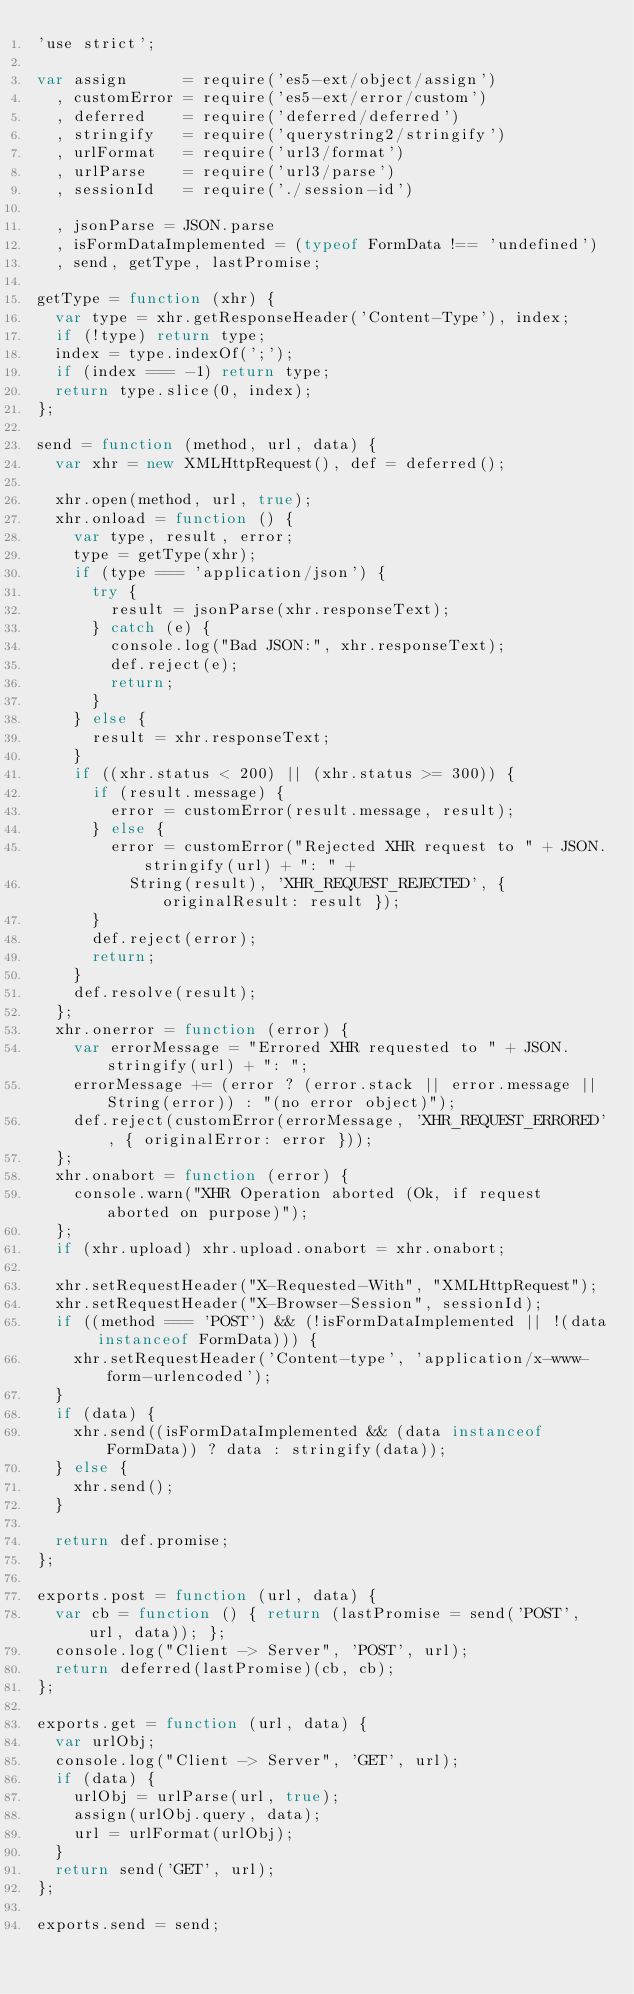<code> <loc_0><loc_0><loc_500><loc_500><_JavaScript_>'use strict';

var assign      = require('es5-ext/object/assign')
  , customError = require('es5-ext/error/custom')
  , deferred    = require('deferred/deferred')
  , stringify   = require('querystring2/stringify')
  , urlFormat   = require('url3/format')
  , urlParse    = require('url3/parse')
  , sessionId   = require('./session-id')

  , jsonParse = JSON.parse
  , isFormDataImplemented = (typeof FormData !== 'undefined')
  , send, getType, lastPromise;

getType = function (xhr) {
	var type = xhr.getResponseHeader('Content-Type'), index;
	if (!type) return type;
	index = type.indexOf(';');
	if (index === -1) return type;
	return type.slice(0, index);
};

send = function (method, url, data) {
	var xhr = new XMLHttpRequest(), def = deferred();

	xhr.open(method, url, true);
	xhr.onload = function () {
		var type, result, error;
		type = getType(xhr);
		if (type === 'application/json') {
			try {
				result = jsonParse(xhr.responseText);
			} catch (e) {
				console.log("Bad JSON:", xhr.responseText);
				def.reject(e);
				return;
			}
		} else {
			result = xhr.responseText;
		}
		if ((xhr.status < 200) || (xhr.status >= 300)) {
			if (result.message) {
				error = customError(result.message, result);
			} else {
				error = customError("Rejected XHR request to " + JSON.stringify(url) + ": " +
					String(result), 'XHR_REQUEST_REJECTED', { originalResult: result });
			}
			def.reject(error);
			return;
		}
		def.resolve(result);
	};
	xhr.onerror = function (error) {
		var errorMessage = "Errored XHR requested to " + JSON.stringify(url) + ": ";
		errorMessage += (error ? (error.stack || error.message || String(error)) : "(no error object)");
		def.reject(customError(errorMessage, 'XHR_REQUEST_ERRORED', { originalError: error }));
	};
	xhr.onabort = function (error) {
		console.warn("XHR Operation aborted (Ok, if request aborted on purpose)");
	};
	if (xhr.upload) xhr.upload.onabort = xhr.onabort;

	xhr.setRequestHeader("X-Requested-With", "XMLHttpRequest");
	xhr.setRequestHeader("X-Browser-Session", sessionId);
	if ((method === 'POST') && (!isFormDataImplemented || !(data instanceof FormData))) {
		xhr.setRequestHeader('Content-type', 'application/x-www-form-urlencoded');
	}
	if (data) {
		xhr.send((isFormDataImplemented && (data instanceof FormData)) ? data : stringify(data));
	} else {
		xhr.send();
	}

	return def.promise;
};

exports.post = function (url, data) {
	var cb = function () { return (lastPromise = send('POST', url, data)); };
	console.log("Client -> Server", 'POST', url);
	return deferred(lastPromise)(cb, cb);
};

exports.get = function (url, data) {
	var urlObj;
	console.log("Client -> Server", 'GET', url);
	if (data) {
		urlObj = urlParse(url, true);
		assign(urlObj.query, data);
		url = urlFormat(urlObj);
	}
	return send('GET', url);
};

exports.send = send;
</code> 